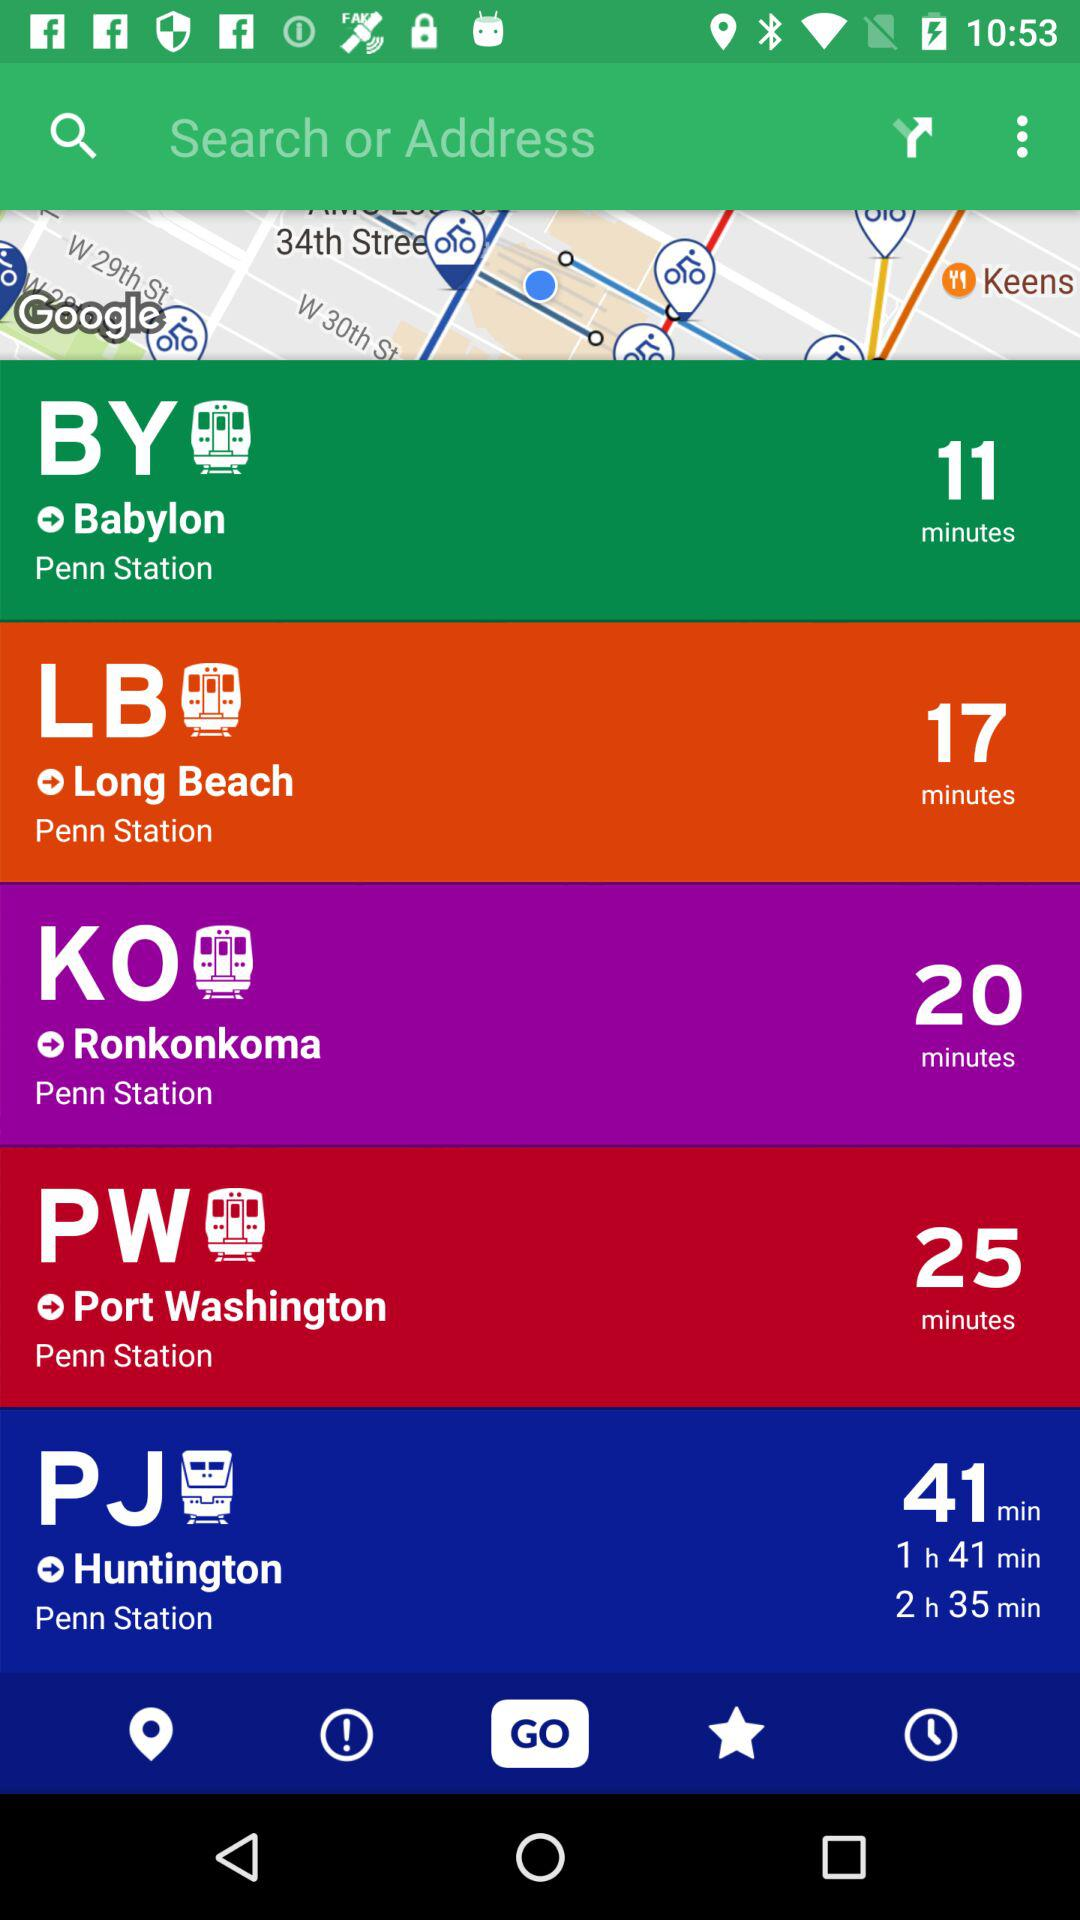How long will it take to reach "Long Beach"? It will take 17 minutes to reach "Long Beach". 